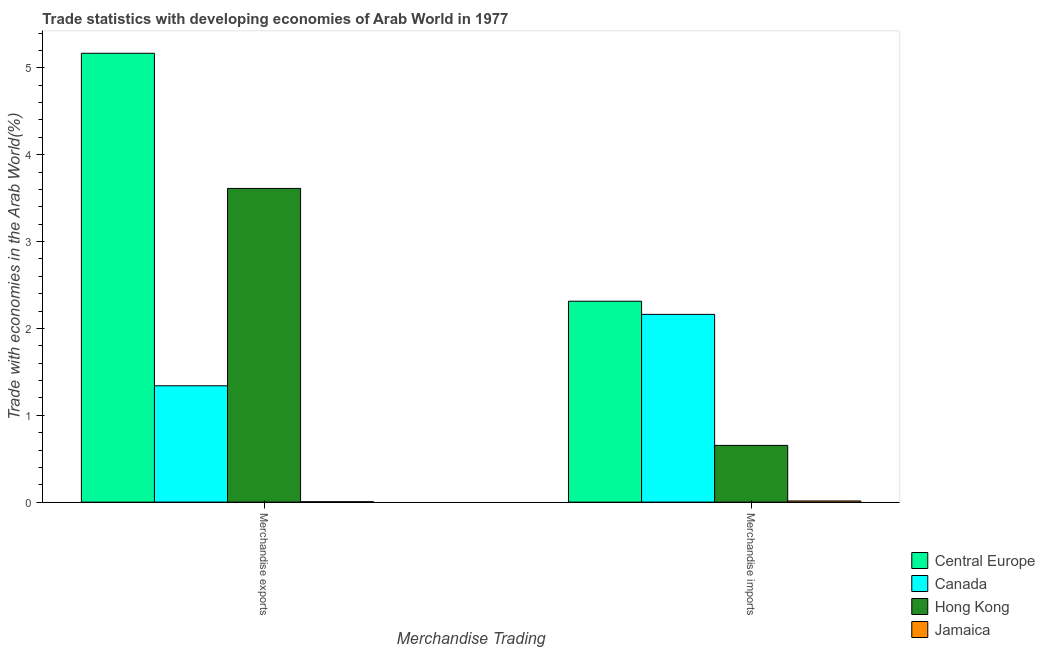How many groups of bars are there?
Make the answer very short. 2. Are the number of bars per tick equal to the number of legend labels?
Provide a short and direct response. Yes. How many bars are there on the 2nd tick from the left?
Keep it short and to the point. 4. What is the merchandise exports in Central Europe?
Keep it short and to the point. 5.17. Across all countries, what is the maximum merchandise imports?
Your response must be concise. 2.31. Across all countries, what is the minimum merchandise imports?
Your response must be concise. 0.01. In which country was the merchandise exports maximum?
Keep it short and to the point. Central Europe. In which country was the merchandise exports minimum?
Your answer should be compact. Jamaica. What is the total merchandise exports in the graph?
Offer a very short reply. 10.12. What is the difference between the merchandise exports in Central Europe and that in Canada?
Provide a short and direct response. 3.83. What is the difference between the merchandise imports in Hong Kong and the merchandise exports in Central Europe?
Your answer should be very brief. -4.51. What is the average merchandise exports per country?
Provide a short and direct response. 2.53. What is the difference between the merchandise imports and merchandise exports in Central Europe?
Your answer should be compact. -2.85. In how many countries, is the merchandise exports greater than 5 %?
Your response must be concise. 1. What is the ratio of the merchandise exports in Central Europe to that in Hong Kong?
Your response must be concise. 1.43. Is the merchandise imports in Canada less than that in Central Europe?
Make the answer very short. Yes. What does the 4th bar from the left in Merchandise imports represents?
Make the answer very short. Jamaica. What does the 2nd bar from the right in Merchandise imports represents?
Your response must be concise. Hong Kong. What is the difference between two consecutive major ticks on the Y-axis?
Provide a succinct answer. 1. Does the graph contain any zero values?
Give a very brief answer. No. Does the graph contain grids?
Provide a short and direct response. No. Where does the legend appear in the graph?
Your response must be concise. Bottom right. What is the title of the graph?
Offer a very short reply. Trade statistics with developing economies of Arab World in 1977. What is the label or title of the X-axis?
Your answer should be very brief. Merchandise Trading. What is the label or title of the Y-axis?
Your answer should be compact. Trade with economies in the Arab World(%). What is the Trade with economies in the Arab World(%) of Central Europe in Merchandise exports?
Keep it short and to the point. 5.17. What is the Trade with economies in the Arab World(%) of Canada in Merchandise exports?
Your answer should be compact. 1.34. What is the Trade with economies in the Arab World(%) in Hong Kong in Merchandise exports?
Your answer should be compact. 3.61. What is the Trade with economies in the Arab World(%) of Jamaica in Merchandise exports?
Your answer should be compact. 0. What is the Trade with economies in the Arab World(%) of Central Europe in Merchandise imports?
Ensure brevity in your answer.  2.31. What is the Trade with economies in the Arab World(%) in Canada in Merchandise imports?
Ensure brevity in your answer.  2.16. What is the Trade with economies in the Arab World(%) in Hong Kong in Merchandise imports?
Your answer should be compact. 0.65. What is the Trade with economies in the Arab World(%) of Jamaica in Merchandise imports?
Give a very brief answer. 0.01. Across all Merchandise Trading, what is the maximum Trade with economies in the Arab World(%) of Central Europe?
Give a very brief answer. 5.17. Across all Merchandise Trading, what is the maximum Trade with economies in the Arab World(%) in Canada?
Provide a short and direct response. 2.16. Across all Merchandise Trading, what is the maximum Trade with economies in the Arab World(%) of Hong Kong?
Provide a succinct answer. 3.61. Across all Merchandise Trading, what is the maximum Trade with economies in the Arab World(%) of Jamaica?
Offer a terse response. 0.01. Across all Merchandise Trading, what is the minimum Trade with economies in the Arab World(%) of Central Europe?
Give a very brief answer. 2.31. Across all Merchandise Trading, what is the minimum Trade with economies in the Arab World(%) of Canada?
Keep it short and to the point. 1.34. Across all Merchandise Trading, what is the minimum Trade with economies in the Arab World(%) of Hong Kong?
Give a very brief answer. 0.65. Across all Merchandise Trading, what is the minimum Trade with economies in the Arab World(%) in Jamaica?
Make the answer very short. 0. What is the total Trade with economies in the Arab World(%) of Central Europe in the graph?
Provide a succinct answer. 7.48. What is the total Trade with economies in the Arab World(%) of Canada in the graph?
Provide a succinct answer. 3.5. What is the total Trade with economies in the Arab World(%) of Hong Kong in the graph?
Provide a short and direct response. 4.26. What is the total Trade with economies in the Arab World(%) in Jamaica in the graph?
Your answer should be compact. 0.02. What is the difference between the Trade with economies in the Arab World(%) of Central Europe in Merchandise exports and that in Merchandise imports?
Your answer should be very brief. 2.85. What is the difference between the Trade with economies in the Arab World(%) in Canada in Merchandise exports and that in Merchandise imports?
Your answer should be very brief. -0.82. What is the difference between the Trade with economies in the Arab World(%) of Hong Kong in Merchandise exports and that in Merchandise imports?
Keep it short and to the point. 2.96. What is the difference between the Trade with economies in the Arab World(%) of Jamaica in Merchandise exports and that in Merchandise imports?
Your response must be concise. -0.01. What is the difference between the Trade with economies in the Arab World(%) in Central Europe in Merchandise exports and the Trade with economies in the Arab World(%) in Canada in Merchandise imports?
Your answer should be compact. 3.01. What is the difference between the Trade with economies in the Arab World(%) in Central Europe in Merchandise exports and the Trade with economies in the Arab World(%) in Hong Kong in Merchandise imports?
Keep it short and to the point. 4.51. What is the difference between the Trade with economies in the Arab World(%) in Central Europe in Merchandise exports and the Trade with economies in the Arab World(%) in Jamaica in Merchandise imports?
Your response must be concise. 5.15. What is the difference between the Trade with economies in the Arab World(%) in Canada in Merchandise exports and the Trade with economies in the Arab World(%) in Hong Kong in Merchandise imports?
Keep it short and to the point. 0.69. What is the difference between the Trade with economies in the Arab World(%) in Canada in Merchandise exports and the Trade with economies in the Arab World(%) in Jamaica in Merchandise imports?
Give a very brief answer. 1.33. What is the difference between the Trade with economies in the Arab World(%) in Hong Kong in Merchandise exports and the Trade with economies in the Arab World(%) in Jamaica in Merchandise imports?
Your response must be concise. 3.6. What is the average Trade with economies in the Arab World(%) of Central Europe per Merchandise Trading?
Your answer should be very brief. 3.74. What is the average Trade with economies in the Arab World(%) of Canada per Merchandise Trading?
Provide a short and direct response. 1.75. What is the average Trade with economies in the Arab World(%) in Hong Kong per Merchandise Trading?
Give a very brief answer. 2.13. What is the average Trade with economies in the Arab World(%) of Jamaica per Merchandise Trading?
Ensure brevity in your answer.  0.01. What is the difference between the Trade with economies in the Arab World(%) in Central Europe and Trade with economies in the Arab World(%) in Canada in Merchandise exports?
Give a very brief answer. 3.83. What is the difference between the Trade with economies in the Arab World(%) in Central Europe and Trade with economies in the Arab World(%) in Hong Kong in Merchandise exports?
Your response must be concise. 1.56. What is the difference between the Trade with economies in the Arab World(%) of Central Europe and Trade with economies in the Arab World(%) of Jamaica in Merchandise exports?
Ensure brevity in your answer.  5.16. What is the difference between the Trade with economies in the Arab World(%) in Canada and Trade with economies in the Arab World(%) in Hong Kong in Merchandise exports?
Offer a very short reply. -2.27. What is the difference between the Trade with economies in the Arab World(%) in Canada and Trade with economies in the Arab World(%) in Jamaica in Merchandise exports?
Your response must be concise. 1.33. What is the difference between the Trade with economies in the Arab World(%) in Hong Kong and Trade with economies in the Arab World(%) in Jamaica in Merchandise exports?
Your response must be concise. 3.61. What is the difference between the Trade with economies in the Arab World(%) of Central Europe and Trade with economies in the Arab World(%) of Canada in Merchandise imports?
Provide a short and direct response. 0.15. What is the difference between the Trade with economies in the Arab World(%) in Central Europe and Trade with economies in the Arab World(%) in Hong Kong in Merchandise imports?
Make the answer very short. 1.66. What is the difference between the Trade with economies in the Arab World(%) in Central Europe and Trade with economies in the Arab World(%) in Jamaica in Merchandise imports?
Make the answer very short. 2.3. What is the difference between the Trade with economies in the Arab World(%) in Canada and Trade with economies in the Arab World(%) in Hong Kong in Merchandise imports?
Give a very brief answer. 1.51. What is the difference between the Trade with economies in the Arab World(%) of Canada and Trade with economies in the Arab World(%) of Jamaica in Merchandise imports?
Keep it short and to the point. 2.15. What is the difference between the Trade with economies in the Arab World(%) of Hong Kong and Trade with economies in the Arab World(%) of Jamaica in Merchandise imports?
Keep it short and to the point. 0.64. What is the ratio of the Trade with economies in the Arab World(%) of Central Europe in Merchandise exports to that in Merchandise imports?
Make the answer very short. 2.23. What is the ratio of the Trade with economies in the Arab World(%) in Canada in Merchandise exports to that in Merchandise imports?
Provide a short and direct response. 0.62. What is the ratio of the Trade with economies in the Arab World(%) of Hong Kong in Merchandise exports to that in Merchandise imports?
Offer a very short reply. 5.53. What is the ratio of the Trade with economies in the Arab World(%) in Jamaica in Merchandise exports to that in Merchandise imports?
Offer a terse response. 0.33. What is the difference between the highest and the second highest Trade with economies in the Arab World(%) in Central Europe?
Offer a very short reply. 2.85. What is the difference between the highest and the second highest Trade with economies in the Arab World(%) in Canada?
Your answer should be very brief. 0.82. What is the difference between the highest and the second highest Trade with economies in the Arab World(%) in Hong Kong?
Make the answer very short. 2.96. What is the difference between the highest and the second highest Trade with economies in the Arab World(%) of Jamaica?
Provide a short and direct response. 0.01. What is the difference between the highest and the lowest Trade with economies in the Arab World(%) of Central Europe?
Make the answer very short. 2.85. What is the difference between the highest and the lowest Trade with economies in the Arab World(%) of Canada?
Ensure brevity in your answer.  0.82. What is the difference between the highest and the lowest Trade with economies in the Arab World(%) of Hong Kong?
Provide a succinct answer. 2.96. What is the difference between the highest and the lowest Trade with economies in the Arab World(%) in Jamaica?
Offer a very short reply. 0.01. 